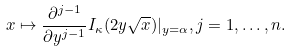<formula> <loc_0><loc_0><loc_500><loc_500>x \mapsto \frac { \partial ^ { j - 1 } } { \partial y ^ { j - 1 } } I _ { \kappa } ( 2 y \sqrt { x } ) | _ { y = \alpha } , j = 1 , \dots , n .</formula> 